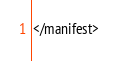<code> <loc_0><loc_0><loc_500><loc_500><_XML_></manifest>
</code> 